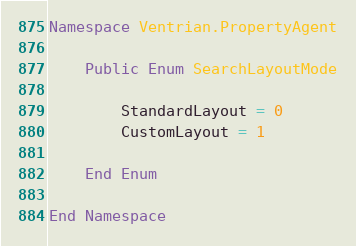Convert code to text. <code><loc_0><loc_0><loc_500><loc_500><_VisualBasic_>Namespace Ventrian.PropertyAgent

    Public Enum SearchLayoutMode

        StandardLayout = 0
        CustomLayout = 1

    End Enum

End Namespace
</code> 